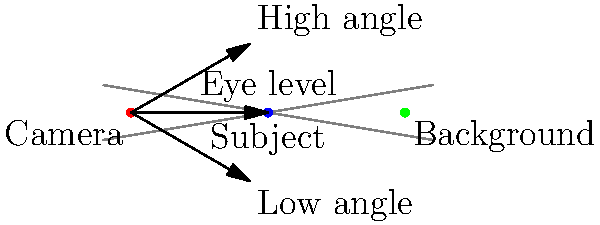In a scene where you want to make the subject appear more powerful and dominant, which camera angle would you choose based on the diagram? To determine the best camera angle for making a subject appear more powerful and dominant, let's consider the options shown in the diagram:

1. High angle: The camera is positioned above the subject, looking down. This angle tends to make the subject appear smaller and less significant, which is not suitable for creating a powerful impression.

2. Eye level: The camera is at the same height as the subject. While this is a neutral angle, it doesn't necessarily enhance the subject's power or dominance.

3. Low angle: The camera is positioned below the subject, looking up. This angle is ideal for making the subject appear larger, more imposing, and more powerful.

In cinematography, a low angle shot is often used to create a sense of power, strength, and dominance for the subject. It makes the subject appear taller and more significant in the frame, which psychologically translates to a feeling of authority or importance for the viewer.

As a retired actor who has likely encountered various camera techniques, you would recognize that the low angle shot is the most effective for creating a powerful and dominant appearance for the subject.
Answer: Low angle 